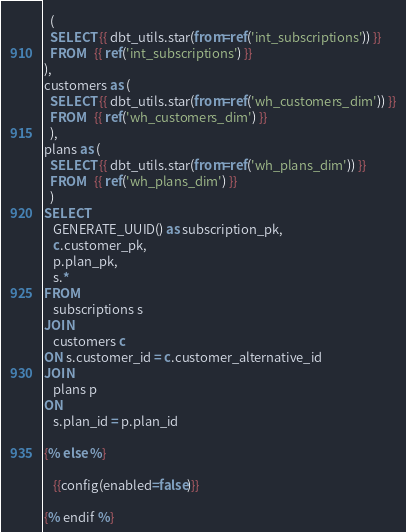<code> <loc_0><loc_0><loc_500><loc_500><_SQL_>  (
  SELECT {{ dbt_utils.star(from=ref('int_subscriptions')) }}
  FROM   {{ ref('int_subscriptions') }}
),
customers as (
  SELECT {{ dbt_utils.star(from=ref('wh_customers_dim')) }}
  FROM   {{ ref('wh_customers_dim') }}
  ),
plans as (
  SELECT {{ dbt_utils.star(from=ref('wh_plans_dim')) }}
  FROM   {{ ref('wh_plans_dim') }}
  )
SELECT
   GENERATE_UUID() as subscription_pk,
   c.customer_pk,
   p.plan_pk,
   s.*
FROM
   subscriptions s
JOIN
   customers c
ON s.customer_id = c.customer_alternative_id
JOIN
   plans p
ON
   s.plan_id = p.plan_id

{% else %}

   {{config(enabled=false)}}

{% endif %}
</code> 